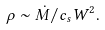<formula> <loc_0><loc_0><loc_500><loc_500>\rho \sim \dot { M } / c _ { s } W ^ { 2 } .</formula> 